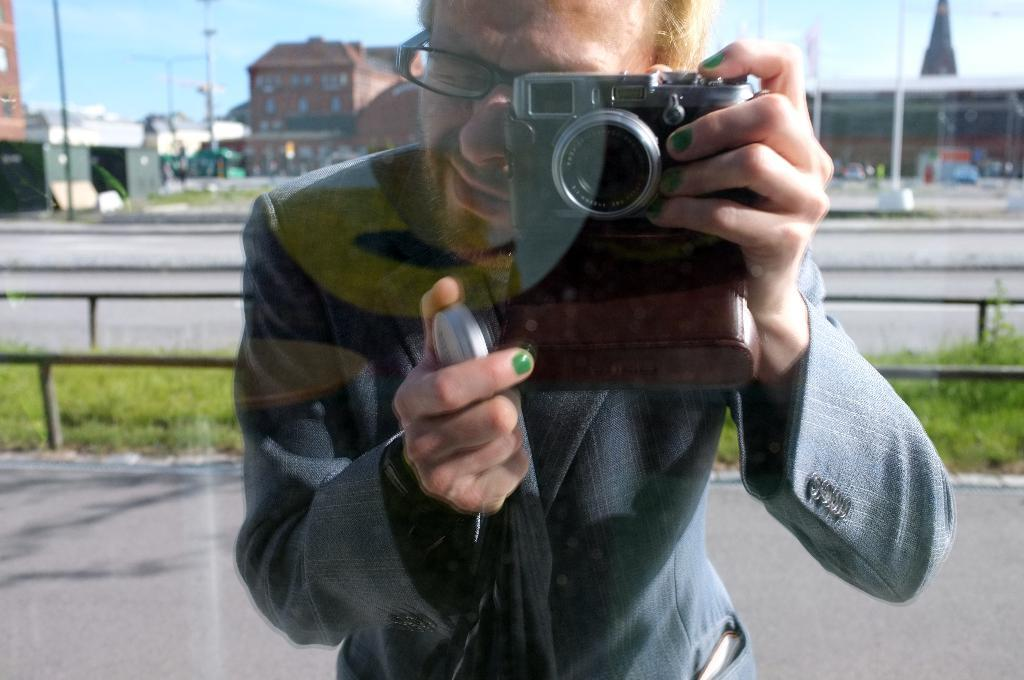What is the person in the image holding? The person in the image is holding a camera. What can be seen in the distance behind the person? There are buildings, a road, and grass in the background of the image. What is visible at the top of the image? The sky is visible at the top of the image. What type of harmony is being played in the scene? There is no music or harmony present in the image; it only features a person holding a camera and the background elements. 